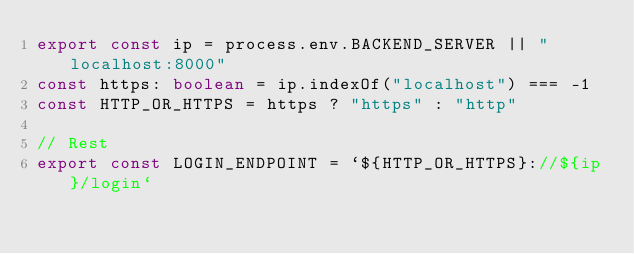Convert code to text. <code><loc_0><loc_0><loc_500><loc_500><_TypeScript_>export const ip = process.env.BACKEND_SERVER || "localhost:8000"
const https: boolean = ip.indexOf("localhost") === -1
const HTTP_OR_HTTPS = https ? "https" : "http"

// Rest
export const LOGIN_ENDPOINT = `${HTTP_OR_HTTPS}://${ip}/login`
</code> 